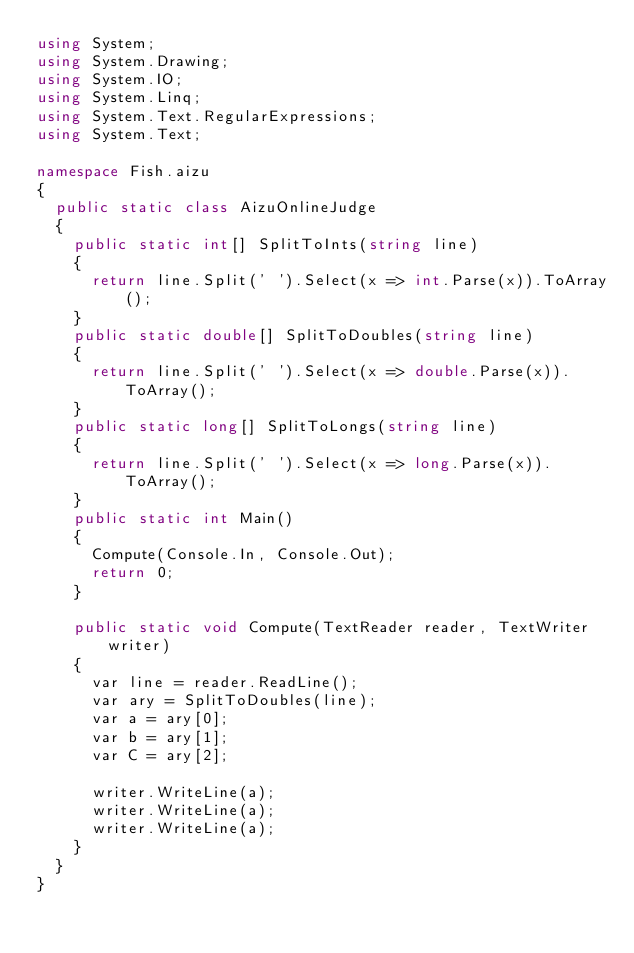Convert code to text. <code><loc_0><loc_0><loc_500><loc_500><_C#_>using System;
using System.Drawing;
using System.IO;
using System.Linq;
using System.Text.RegularExpressions;
using System.Text;

namespace Fish.aizu
{
	public static class AizuOnlineJudge
	{
		public static int[] SplitToInts(string line)
		{
			return line.Split(' ').Select(x => int.Parse(x)).ToArray();
		}
		public static double[] SplitToDoubles(string line)
		{
			return line.Split(' ').Select(x => double.Parse(x)).ToArray();
		}
		public static long[] SplitToLongs(string line)
		{
			return line.Split(' ').Select(x => long.Parse(x)).ToArray();
		}
		public static int Main()
		{
			Compute(Console.In, Console.Out);
			return 0;
		}
		
		public static void Compute(TextReader reader, TextWriter writer)
		{
			var line = reader.ReadLine();
			var ary = SplitToDoubles(line);
			var a = ary[0];
			var b = ary[1];
			var C = ary[2];
			
			writer.WriteLine(a);
			writer.WriteLine(a);
			writer.WriteLine(a);
		}
	}
}</code> 